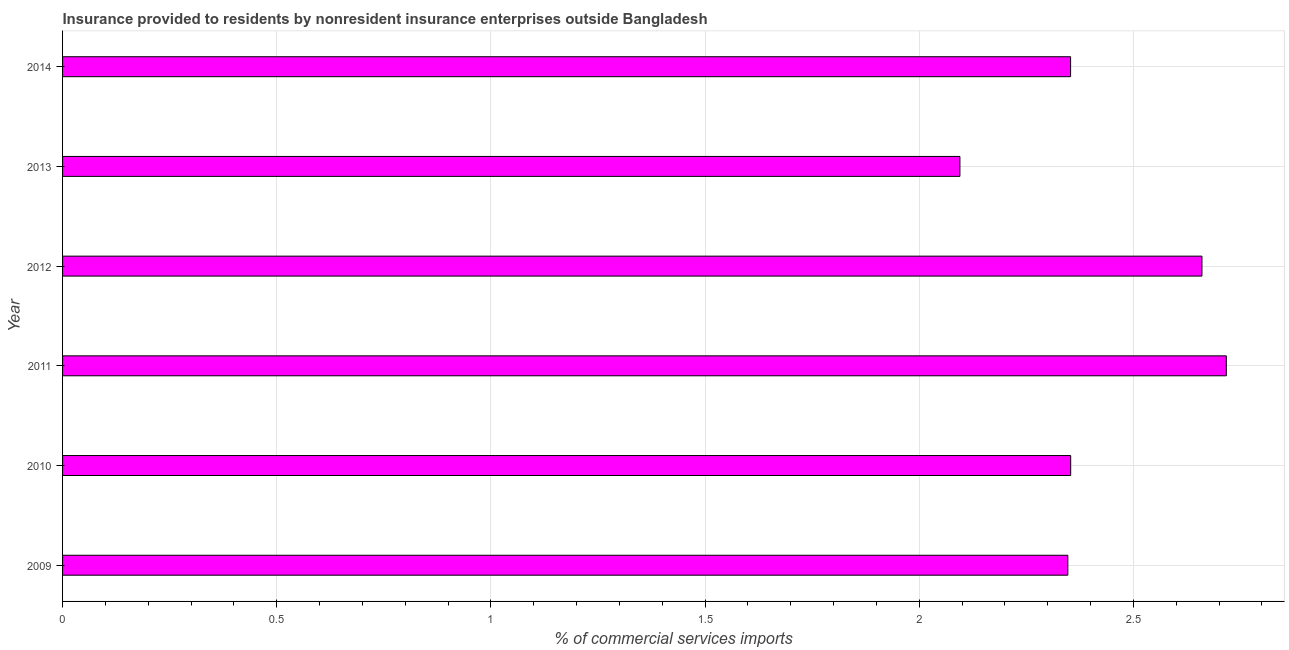Does the graph contain any zero values?
Give a very brief answer. No. What is the title of the graph?
Your answer should be compact. Insurance provided to residents by nonresident insurance enterprises outside Bangladesh. What is the label or title of the X-axis?
Offer a terse response. % of commercial services imports. What is the insurance provided by non-residents in 2009?
Ensure brevity in your answer.  2.35. Across all years, what is the maximum insurance provided by non-residents?
Your answer should be compact. 2.72. Across all years, what is the minimum insurance provided by non-residents?
Your answer should be compact. 2.1. In which year was the insurance provided by non-residents minimum?
Ensure brevity in your answer.  2013. What is the sum of the insurance provided by non-residents?
Provide a succinct answer. 14.53. What is the difference between the insurance provided by non-residents in 2010 and 2013?
Provide a short and direct response. 0.26. What is the average insurance provided by non-residents per year?
Your answer should be very brief. 2.42. What is the median insurance provided by non-residents?
Offer a terse response. 2.35. Do a majority of the years between 2014 and 2010 (inclusive) have insurance provided by non-residents greater than 0.8 %?
Provide a short and direct response. Yes. Is the insurance provided by non-residents in 2010 less than that in 2012?
Your response must be concise. Yes. What is the difference between the highest and the second highest insurance provided by non-residents?
Your response must be concise. 0.06. Is the sum of the insurance provided by non-residents in 2009 and 2012 greater than the maximum insurance provided by non-residents across all years?
Ensure brevity in your answer.  Yes. What is the difference between the highest and the lowest insurance provided by non-residents?
Your answer should be very brief. 0.62. Are all the bars in the graph horizontal?
Your answer should be very brief. Yes. What is the % of commercial services imports of 2009?
Your answer should be very brief. 2.35. What is the % of commercial services imports of 2010?
Ensure brevity in your answer.  2.35. What is the % of commercial services imports of 2011?
Keep it short and to the point. 2.72. What is the % of commercial services imports in 2012?
Your response must be concise. 2.66. What is the % of commercial services imports of 2013?
Provide a succinct answer. 2.1. What is the % of commercial services imports of 2014?
Your response must be concise. 2.35. What is the difference between the % of commercial services imports in 2009 and 2010?
Provide a succinct answer. -0.01. What is the difference between the % of commercial services imports in 2009 and 2011?
Provide a short and direct response. -0.37. What is the difference between the % of commercial services imports in 2009 and 2012?
Keep it short and to the point. -0.31. What is the difference between the % of commercial services imports in 2009 and 2013?
Ensure brevity in your answer.  0.25. What is the difference between the % of commercial services imports in 2009 and 2014?
Your answer should be very brief. -0.01. What is the difference between the % of commercial services imports in 2010 and 2011?
Keep it short and to the point. -0.36. What is the difference between the % of commercial services imports in 2010 and 2012?
Your response must be concise. -0.31. What is the difference between the % of commercial services imports in 2010 and 2013?
Your answer should be compact. 0.26. What is the difference between the % of commercial services imports in 2010 and 2014?
Ensure brevity in your answer.  0. What is the difference between the % of commercial services imports in 2011 and 2012?
Keep it short and to the point. 0.06. What is the difference between the % of commercial services imports in 2011 and 2013?
Offer a terse response. 0.62. What is the difference between the % of commercial services imports in 2011 and 2014?
Provide a short and direct response. 0.36. What is the difference between the % of commercial services imports in 2012 and 2013?
Make the answer very short. 0.57. What is the difference between the % of commercial services imports in 2012 and 2014?
Ensure brevity in your answer.  0.31. What is the difference between the % of commercial services imports in 2013 and 2014?
Offer a very short reply. -0.26. What is the ratio of the % of commercial services imports in 2009 to that in 2011?
Your response must be concise. 0.86. What is the ratio of the % of commercial services imports in 2009 to that in 2012?
Keep it short and to the point. 0.88. What is the ratio of the % of commercial services imports in 2009 to that in 2013?
Offer a terse response. 1.12. What is the ratio of the % of commercial services imports in 2010 to that in 2011?
Ensure brevity in your answer.  0.87. What is the ratio of the % of commercial services imports in 2010 to that in 2012?
Ensure brevity in your answer.  0.89. What is the ratio of the % of commercial services imports in 2010 to that in 2013?
Your answer should be very brief. 1.12. What is the ratio of the % of commercial services imports in 2011 to that in 2013?
Offer a terse response. 1.3. What is the ratio of the % of commercial services imports in 2011 to that in 2014?
Make the answer very short. 1.15. What is the ratio of the % of commercial services imports in 2012 to that in 2013?
Your answer should be compact. 1.27. What is the ratio of the % of commercial services imports in 2012 to that in 2014?
Ensure brevity in your answer.  1.13. What is the ratio of the % of commercial services imports in 2013 to that in 2014?
Your answer should be compact. 0.89. 